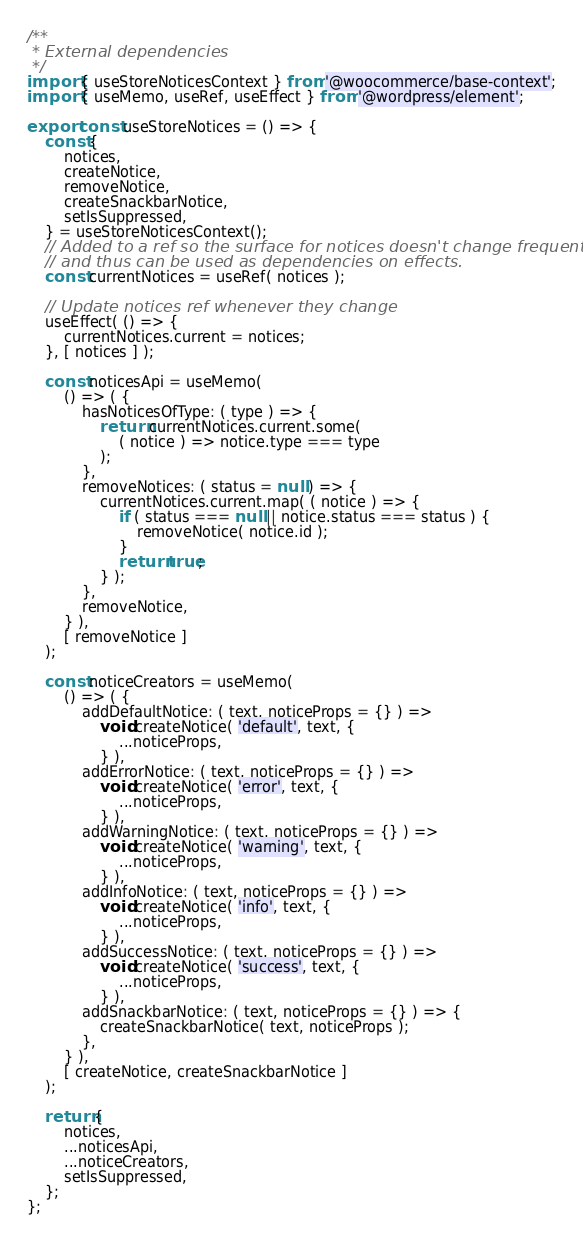Convert code to text. <code><loc_0><loc_0><loc_500><loc_500><_JavaScript_>/**
 * External dependencies
 */
import { useStoreNoticesContext } from '@woocommerce/base-context';
import { useMemo, useRef, useEffect } from '@wordpress/element';

export const useStoreNotices = () => {
	const {
		notices,
		createNotice,
		removeNotice,
		createSnackbarNotice,
		setIsSuppressed,
	} = useStoreNoticesContext();
	// Added to a ref so the surface for notices doesn't change frequently
	// and thus can be used as dependencies on effects.
	const currentNotices = useRef( notices );

	// Update notices ref whenever they change
	useEffect( () => {
		currentNotices.current = notices;
	}, [ notices ] );

	const noticesApi = useMemo(
		() => ( {
			hasNoticesOfType: ( type ) => {
				return currentNotices.current.some(
					( notice ) => notice.type === type
				);
			},
			removeNotices: ( status = null ) => {
				currentNotices.current.map( ( notice ) => {
					if ( status === null || notice.status === status ) {
						removeNotice( notice.id );
					}
					return true;
				} );
			},
			removeNotice,
		} ),
		[ removeNotice ]
	);

	const noticeCreators = useMemo(
		() => ( {
			addDefaultNotice: ( text, noticeProps = {} ) =>
				void createNotice( 'default', text, {
					...noticeProps,
				} ),
			addErrorNotice: ( text, noticeProps = {} ) =>
				void createNotice( 'error', text, {
					...noticeProps,
				} ),
			addWarningNotice: ( text, noticeProps = {} ) =>
				void createNotice( 'warning', text, {
					...noticeProps,
				} ),
			addInfoNotice: ( text, noticeProps = {} ) =>
				void createNotice( 'info', text, {
					...noticeProps,
				} ),
			addSuccessNotice: ( text, noticeProps = {} ) =>
				void createNotice( 'success', text, {
					...noticeProps,
				} ),
			addSnackbarNotice: ( text, noticeProps = {} ) => {
				createSnackbarNotice( text, noticeProps );
			},
		} ),
		[ createNotice, createSnackbarNotice ]
	);

	return {
		notices,
		...noticesApi,
		...noticeCreators,
		setIsSuppressed,
	};
};
</code> 